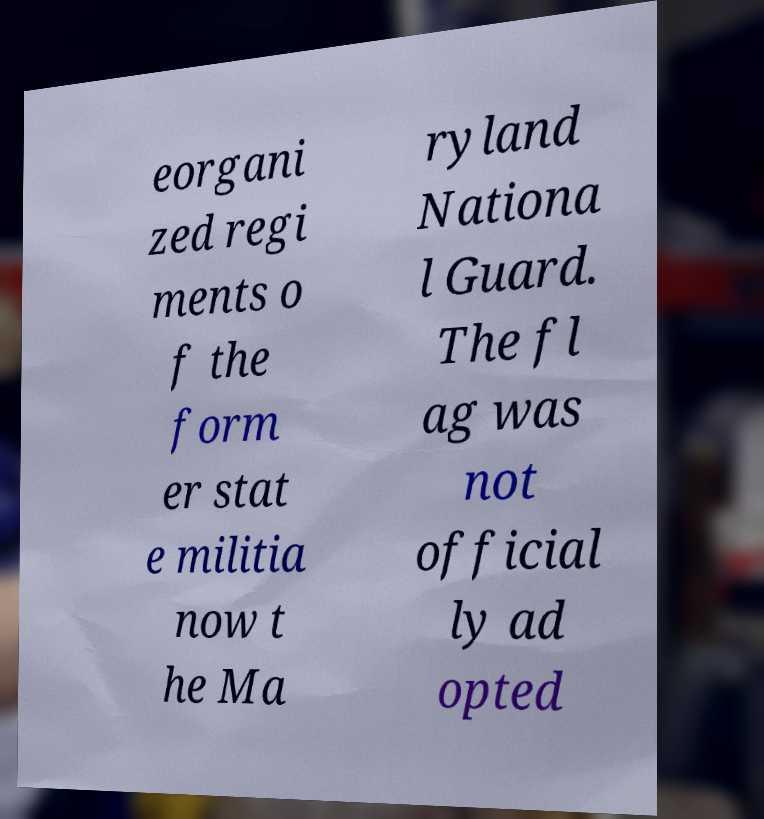What messages or text are displayed in this image? I need them in a readable, typed format. eorgani zed regi ments o f the form er stat e militia now t he Ma ryland Nationa l Guard. The fl ag was not official ly ad opted 